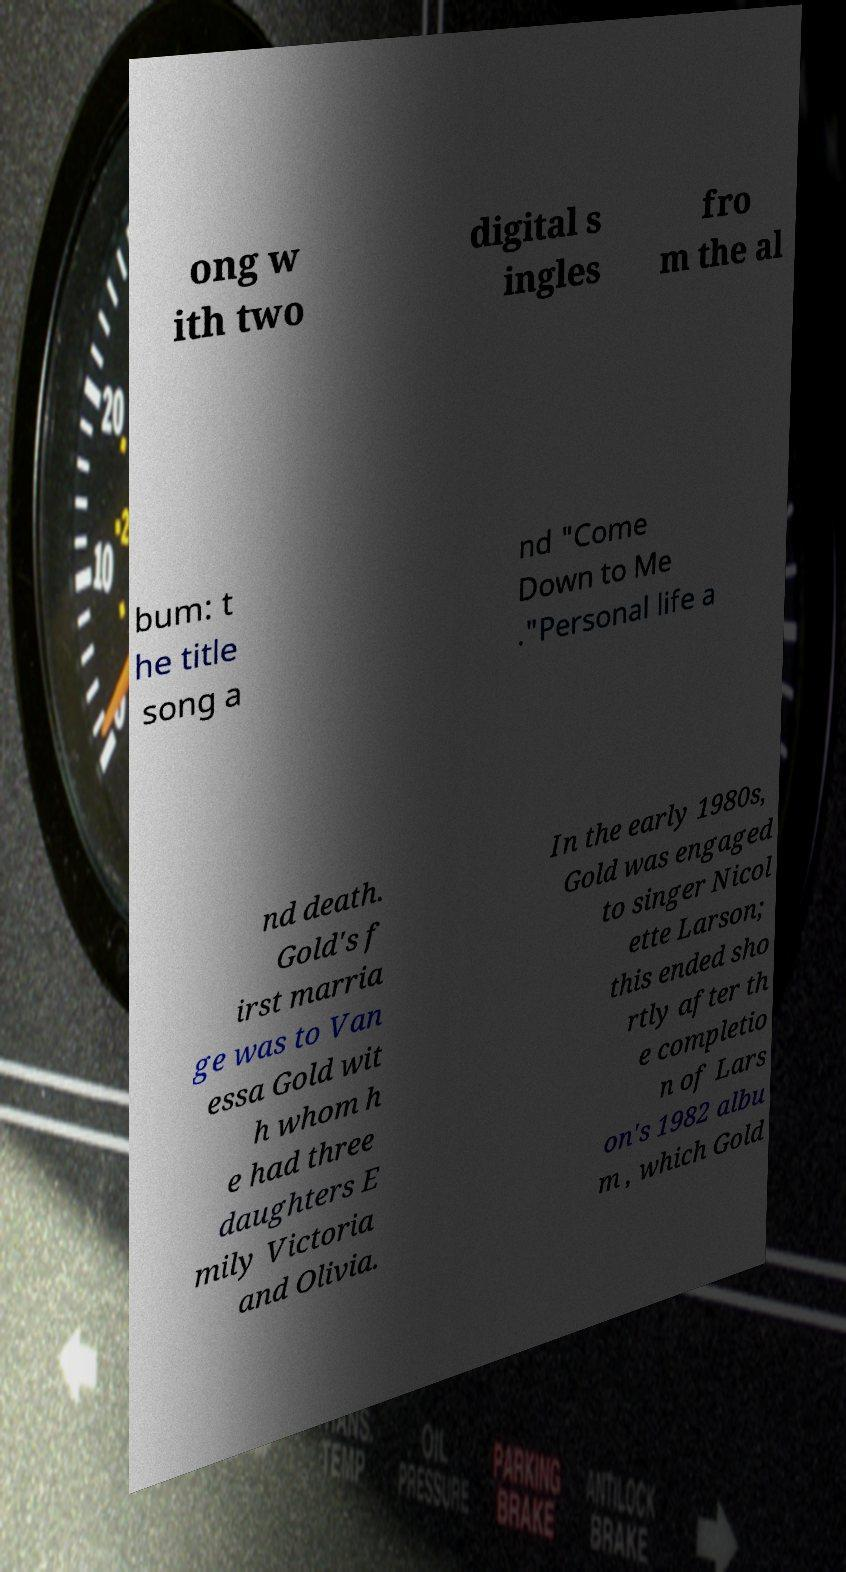For documentation purposes, I need the text within this image transcribed. Could you provide that? ong w ith two digital s ingles fro m the al bum: t he title song a nd "Come Down to Me ."Personal life a nd death. Gold's f irst marria ge was to Van essa Gold wit h whom h e had three daughters E mily Victoria and Olivia. In the early 1980s, Gold was engaged to singer Nicol ette Larson; this ended sho rtly after th e completio n of Lars on's 1982 albu m , which Gold 